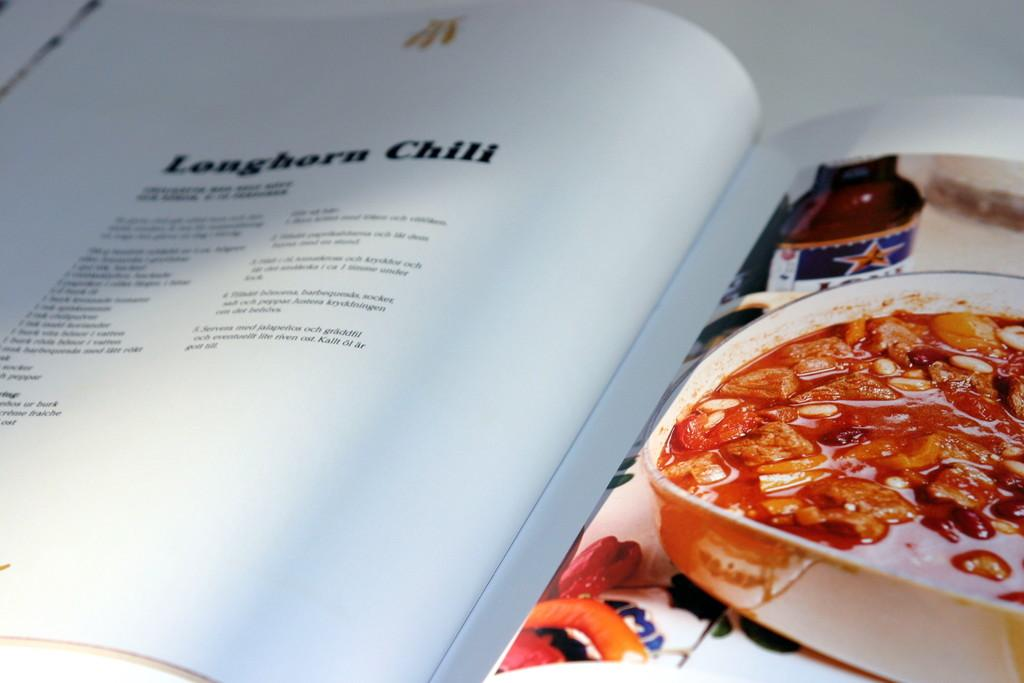What is the main object in the image? There is a recipe book in the image. Where is the recipe book located? The recipe book is placed on a table. What type of brain is being used to illuminate the recipe book in the image? There is no brain or bulb present in the image, and the recipe book is not being illuminated. Is there a railway visible in the image? There is no railway present in the image. 